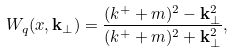<formula> <loc_0><loc_0><loc_500><loc_500>W _ { q } ( x , { \mathbf k } _ { \perp } ) = \frac { ( k ^ { + } + m ) ^ { 2 } - { \mathbf k } ^ { 2 } _ { \perp } } { ( k ^ { + } + m ) ^ { 2 } + { \mathbf k } ^ { 2 } _ { \perp } } ,</formula> 